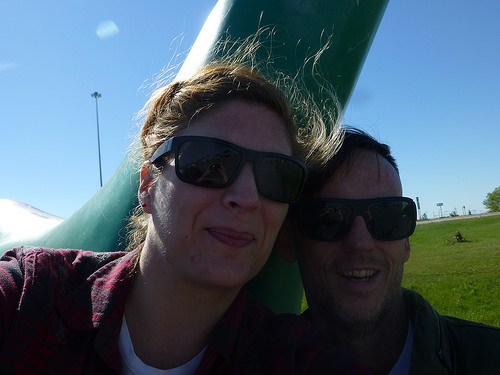<image>
Is the cooling glass on the lady? No. The cooling glass is not positioned on the lady. They may be near each other, but the cooling glass is not supported by or resting on top of the lady. 